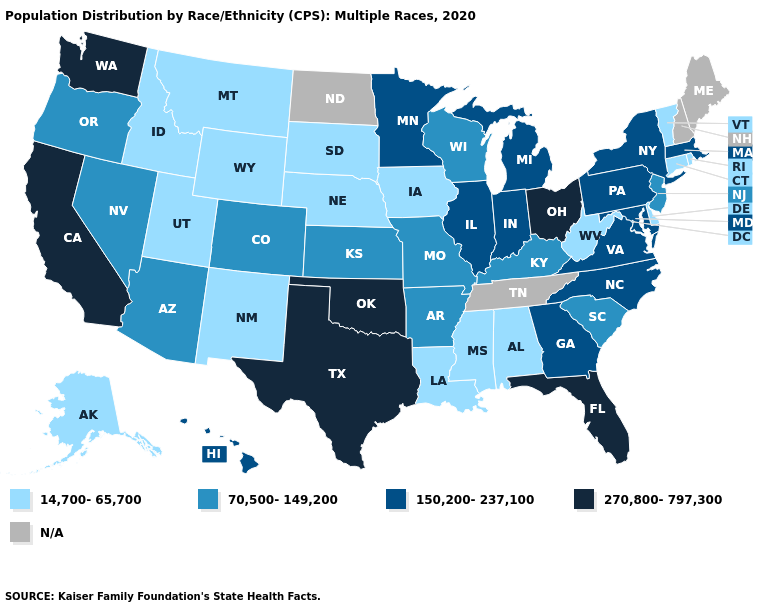Name the states that have a value in the range 150,200-237,100?
Answer briefly. Georgia, Hawaii, Illinois, Indiana, Maryland, Massachusetts, Michigan, Minnesota, New York, North Carolina, Pennsylvania, Virginia. Name the states that have a value in the range 270,800-797,300?
Give a very brief answer. California, Florida, Ohio, Oklahoma, Texas, Washington. Does Vermont have the highest value in the Northeast?
Write a very short answer. No. Which states have the highest value in the USA?
Short answer required. California, Florida, Ohio, Oklahoma, Texas, Washington. Name the states that have a value in the range 270,800-797,300?
Short answer required. California, Florida, Ohio, Oklahoma, Texas, Washington. Which states have the highest value in the USA?
Give a very brief answer. California, Florida, Ohio, Oklahoma, Texas, Washington. Does the first symbol in the legend represent the smallest category?
Quick response, please. Yes. What is the value of Iowa?
Give a very brief answer. 14,700-65,700. Name the states that have a value in the range 70,500-149,200?
Be succinct. Arizona, Arkansas, Colorado, Kansas, Kentucky, Missouri, Nevada, New Jersey, Oregon, South Carolina, Wisconsin. What is the value of Missouri?
Concise answer only. 70,500-149,200. Which states have the lowest value in the MidWest?
Be succinct. Iowa, Nebraska, South Dakota. Does the first symbol in the legend represent the smallest category?
Keep it brief. Yes. Does the map have missing data?
Answer briefly. Yes. Which states have the lowest value in the MidWest?
Concise answer only. Iowa, Nebraska, South Dakota. What is the lowest value in the USA?
Quick response, please. 14,700-65,700. 